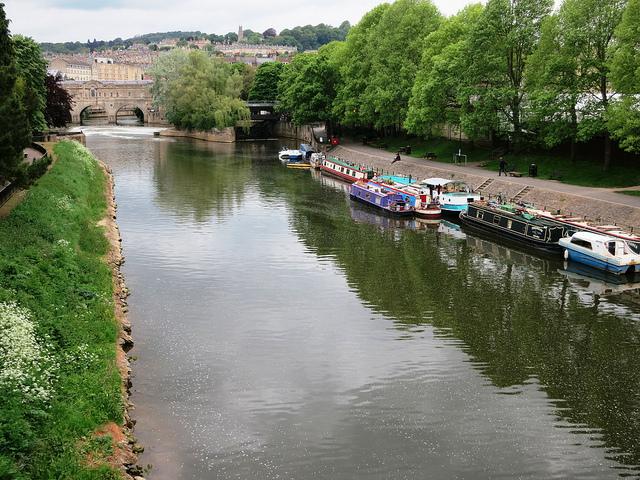How many boats are in the picture?
Short answer required. 7. Is this the Queen river?
Write a very short answer. Yes. What color is the water?
Concise answer only. Green. 